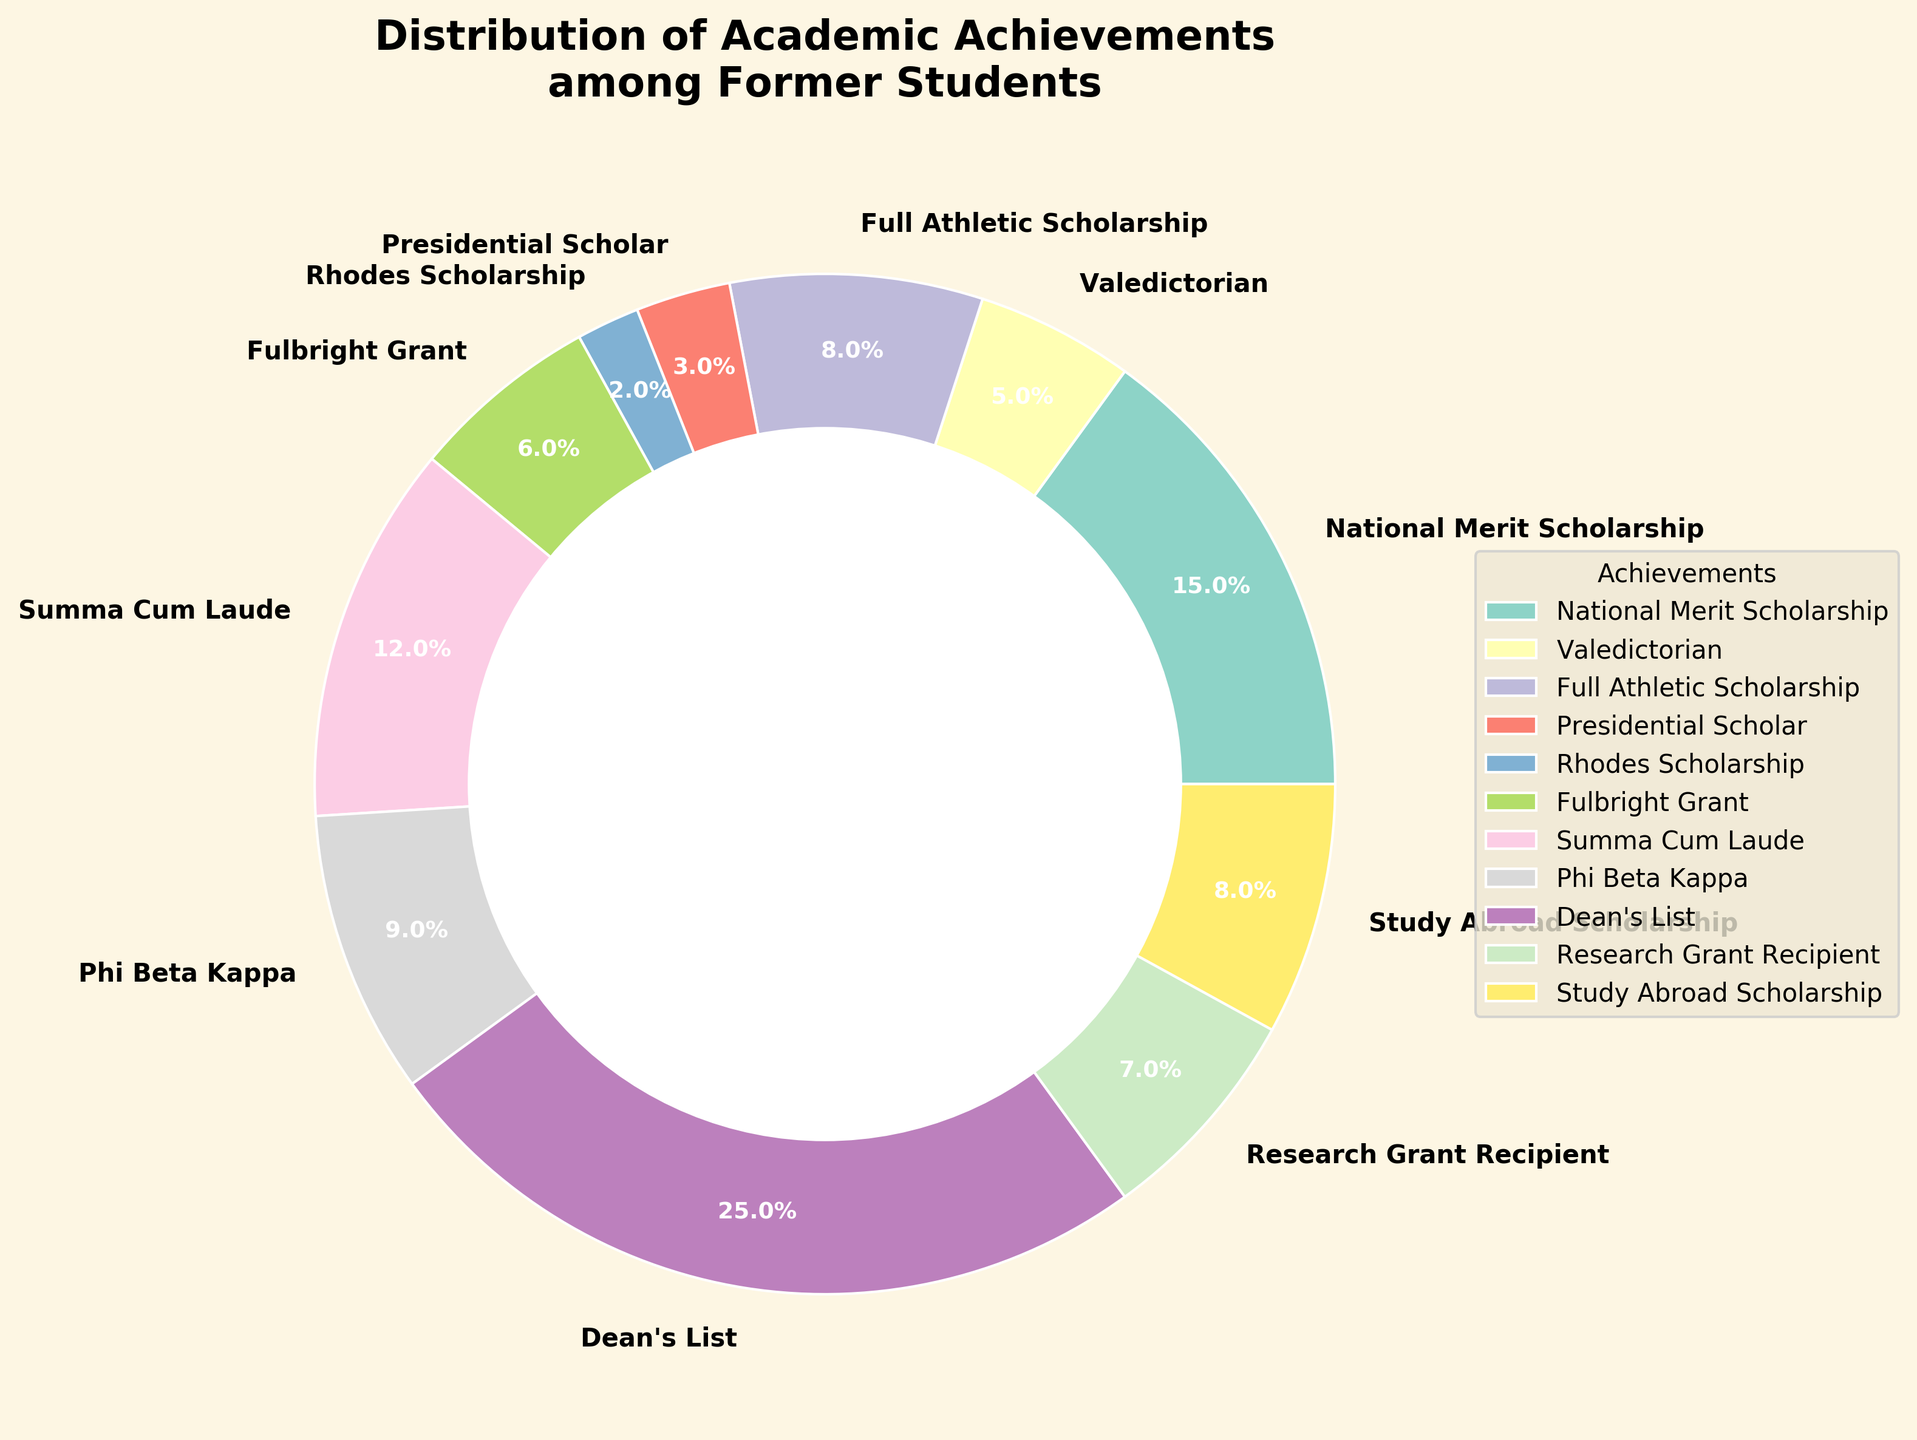What is the most common academic achievement among the former students? The pie chart visually shows that the "Dean's List" segment has the largest proportion, indicated by the largest wedge.
Answer: Dean's List How many times more common is the Dean's List achievement compared to the Rhodes Scholarship? The pie chart shows 25% for the Dean's List and 2% for the Rhodes Scholarship. Dividing 25 by 2 gives the answer.
Answer: 12.5 times What is the combined percentage of students who received athletic and study abroad scholarships? The pie chart lists the percentages for "Full Athletic Scholarship" and "Study Abroad Scholarship" as 8% each. Adding these together gives the answer.
Answer: 16% Which achievements have a percentage below 5%? Observing the pie chart, achievements below 5% are "Valedictorian" (5%) and "Presidential Scholar" (3%) and "Rhodes Scholarship" (2%).
Answer: Valedictorian, Presidential Scholar, Rhodes Scholarship Which achievement has the smallest representation, and what is its percentage? The pie chart visually shows that "Rhodes Scholarship" occupies the smallest wedge, corresponding to 2%.
Answer: Rhodes Scholarship, 2% Among the achievements, how many categories have a greater percentage than Phi Beta Kappa? "Phi Beta Kappa" has a percentage of 9%. From the pie chart, the categories with more than 9% are "Dean's List" (25%), "National Merit Scholarship" (15%), and "Summa Cum Laude" (12%).
Answer: 3 categories What is the percentage difference between Summa Cum Laude and Fulbright Grant recipients? The pie chart shows "Summa Cum Laude" with 12% and "Fulbright Grant" with 6%. The difference is calculated as 12% - 6%.
Answer: 6% Which achievements account for a total of exactly 20% when combined? By examining different combinations, "Summa Cum Laude" (12%) and "Research Grant Recipient" (7%) add up to 19%, which isn’t correct. Another combination like "Full Athletic Scholarship" (8%) and "Study Abroad Scholarship" (8%) also doesn’t suffice. However, "National Merit Scholarship" (15%) and "Presidential Scholar" (3%) add up to 18%. Combination testing with "Phi Beta Kappa" (9%) and "Research Grant Recipient" (7%) tally to 16%. Thus, 20% doesn't sum exactly to provide a valid answer.
Answer: No exact combination By how much does the percentage of National Merit Scholarship recipients exceed that of Research Grant recipients? The pie chart shows "National Merit Scholarship" at 15% and "Research Grant Recipient" at 7%. The difference is calculated as 15% - 7%.
Answer: 8% What is the overall percentage of students receiving either Merit or athletic-based scholarships? The "National Merit Scholarship" is 15%, and the "Full Athletic Scholarship" is 8%. Adding these gives 15% + 8%.
Answer: 23% 